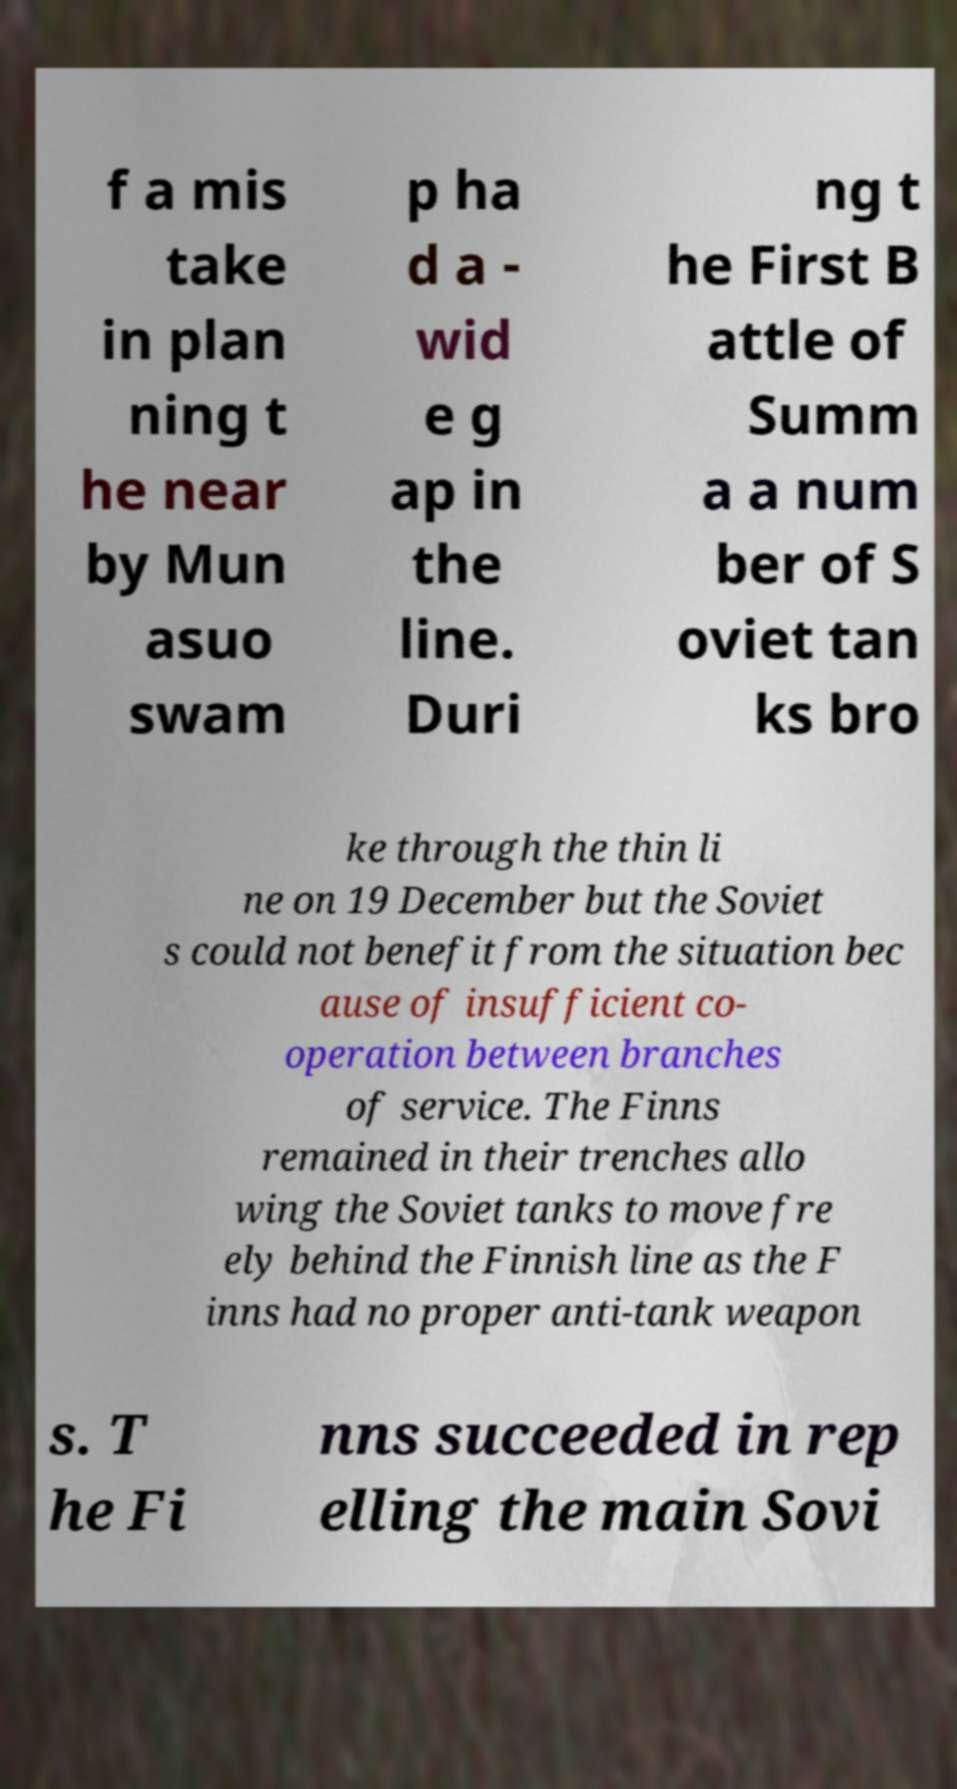There's text embedded in this image that I need extracted. Can you transcribe it verbatim? f a mis take in plan ning t he near by Mun asuo swam p ha d a - wid e g ap in the line. Duri ng t he First B attle of Summ a a num ber of S oviet tan ks bro ke through the thin li ne on 19 December but the Soviet s could not benefit from the situation bec ause of insufficient co- operation between branches of service. The Finns remained in their trenches allo wing the Soviet tanks to move fre ely behind the Finnish line as the F inns had no proper anti-tank weapon s. T he Fi nns succeeded in rep elling the main Sovi 